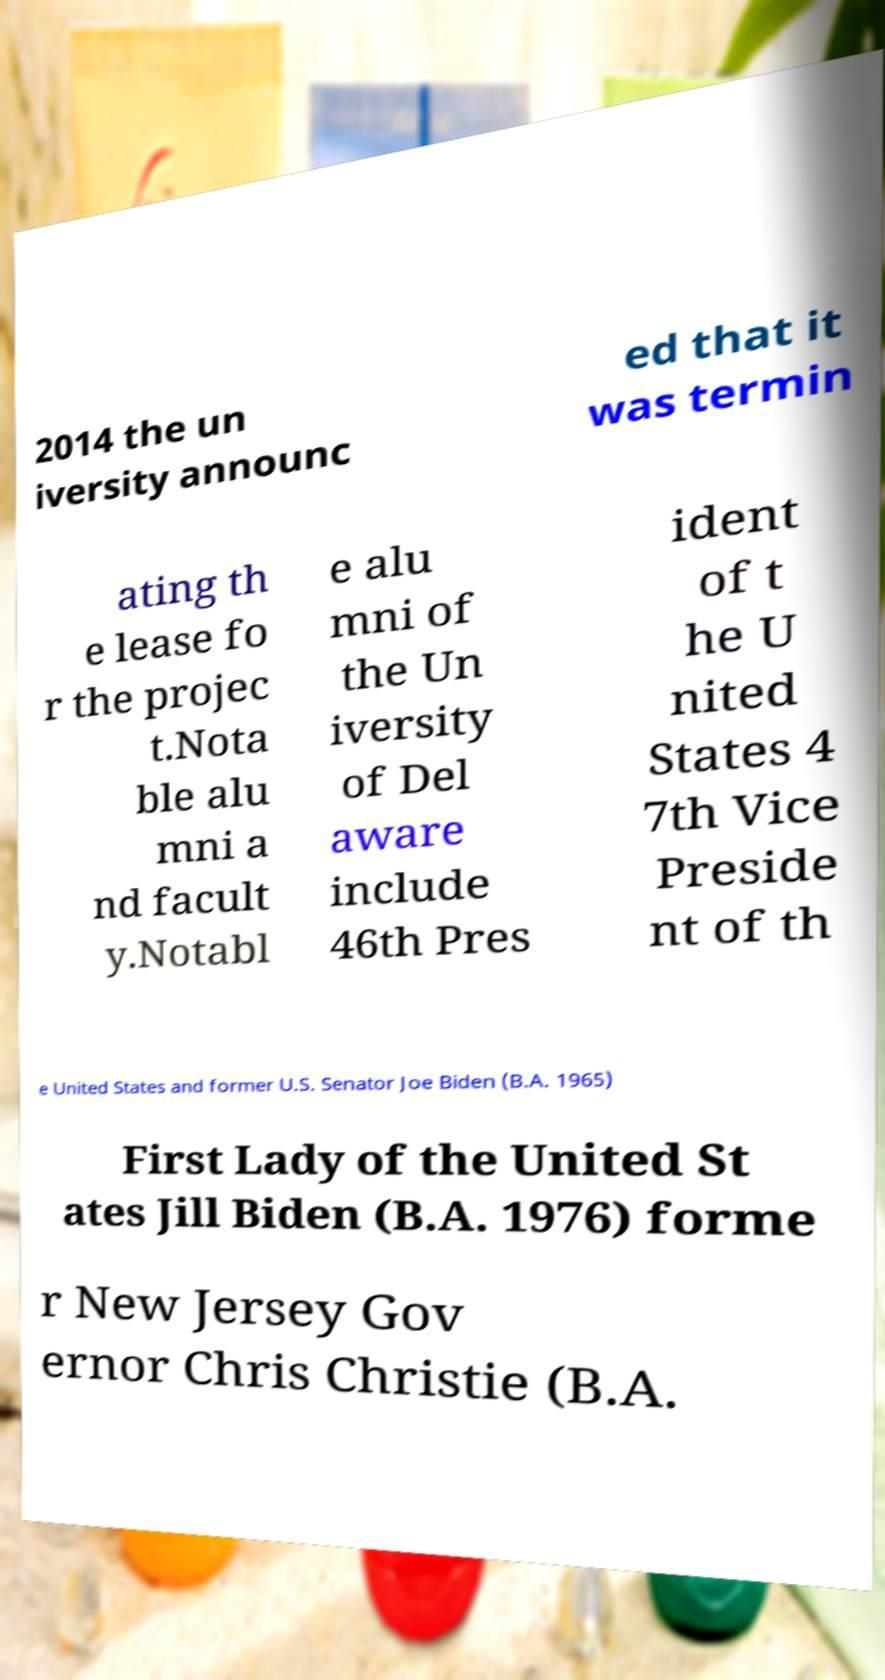I need the written content from this picture converted into text. Can you do that? 2014 the un iversity announc ed that it was termin ating th e lease fo r the projec t.Nota ble alu mni a nd facult y.Notabl e alu mni of the Un iversity of Del aware include 46th Pres ident of t he U nited States 4 7th Vice Preside nt of th e United States and former U.S. Senator Joe Biden (B.A. 1965) First Lady of the United St ates Jill Biden (B.A. 1976) forme r New Jersey Gov ernor Chris Christie (B.A. 